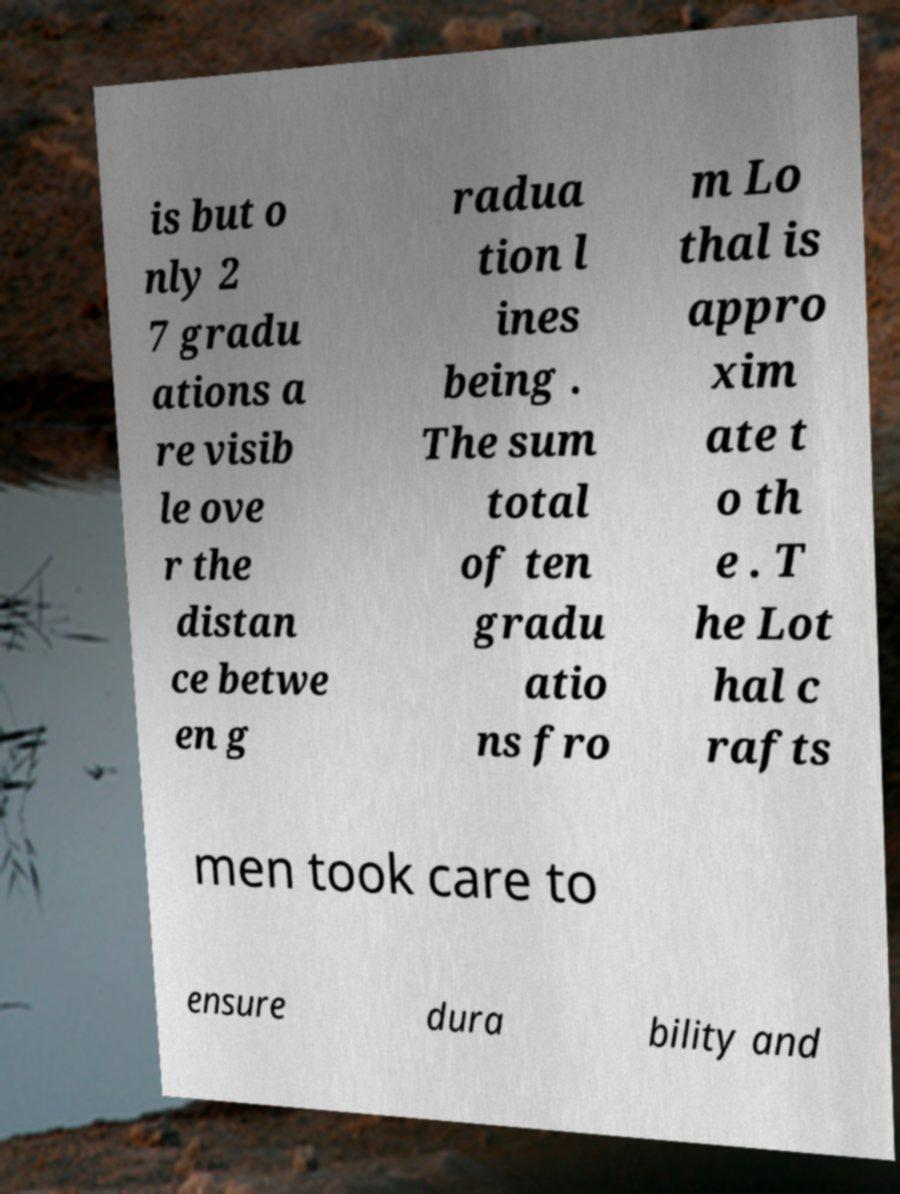Can you read and provide the text displayed in the image?This photo seems to have some interesting text. Can you extract and type it out for me? is but o nly 2 7 gradu ations a re visib le ove r the distan ce betwe en g radua tion l ines being . The sum total of ten gradu atio ns fro m Lo thal is appro xim ate t o th e . T he Lot hal c rafts men took care to ensure dura bility and 